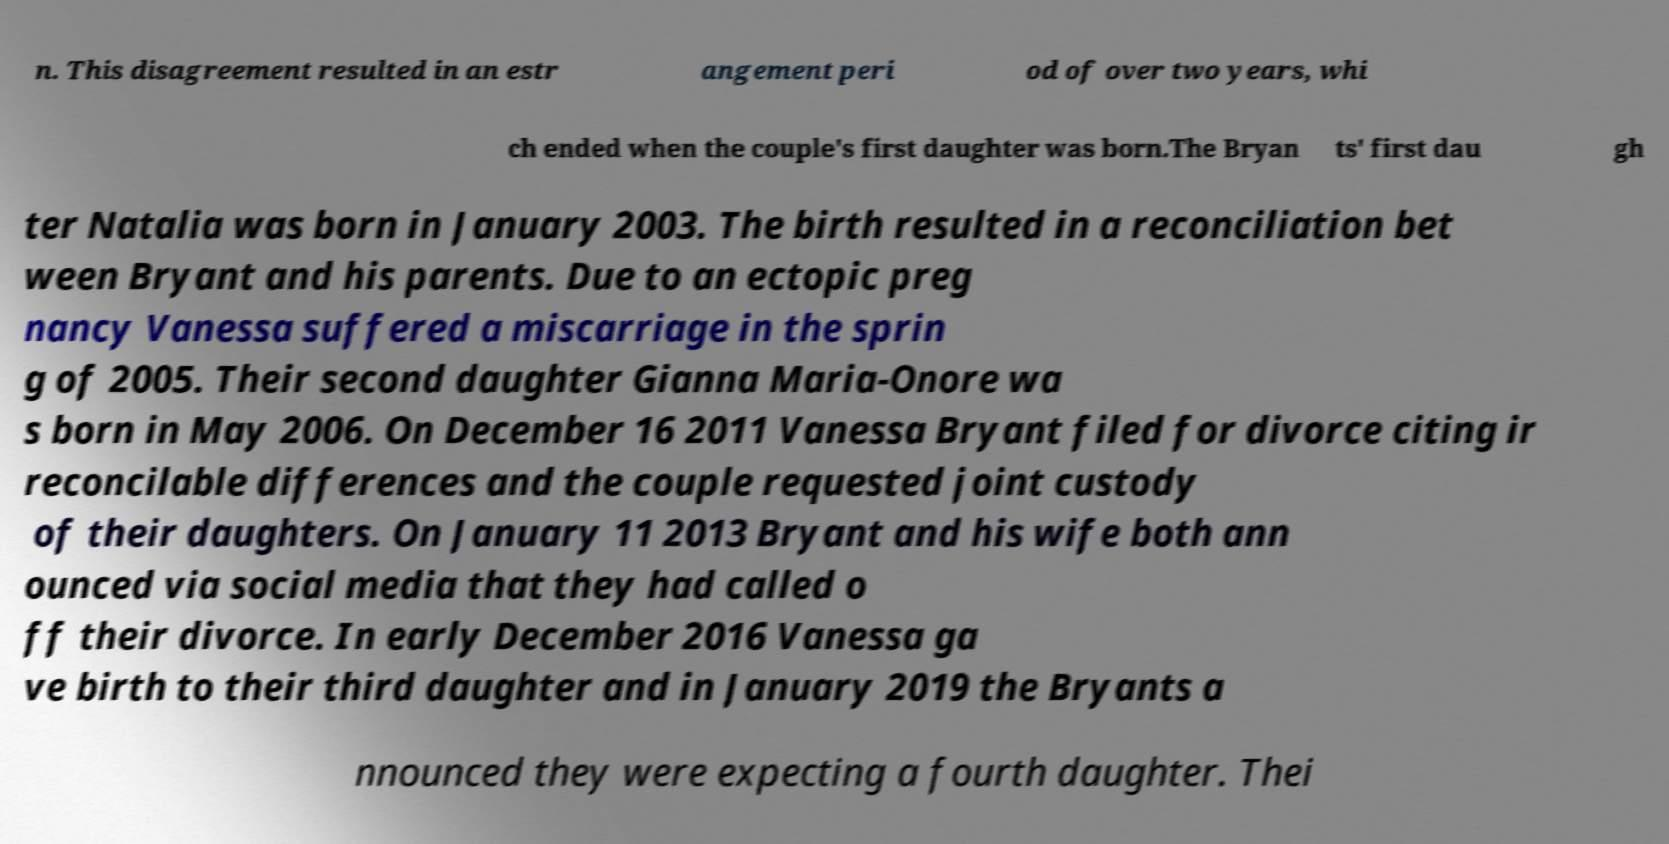Please read and relay the text visible in this image. What does it say? n. This disagreement resulted in an estr angement peri od of over two years, whi ch ended when the couple's first daughter was born.The Bryan ts' first dau gh ter Natalia was born in January 2003. The birth resulted in a reconciliation bet ween Bryant and his parents. Due to an ectopic preg nancy Vanessa suffered a miscarriage in the sprin g of 2005. Their second daughter Gianna Maria-Onore wa s born in May 2006. On December 16 2011 Vanessa Bryant filed for divorce citing ir reconcilable differences and the couple requested joint custody of their daughters. On January 11 2013 Bryant and his wife both ann ounced via social media that they had called o ff their divorce. In early December 2016 Vanessa ga ve birth to their third daughter and in January 2019 the Bryants a nnounced they were expecting a fourth daughter. Thei 